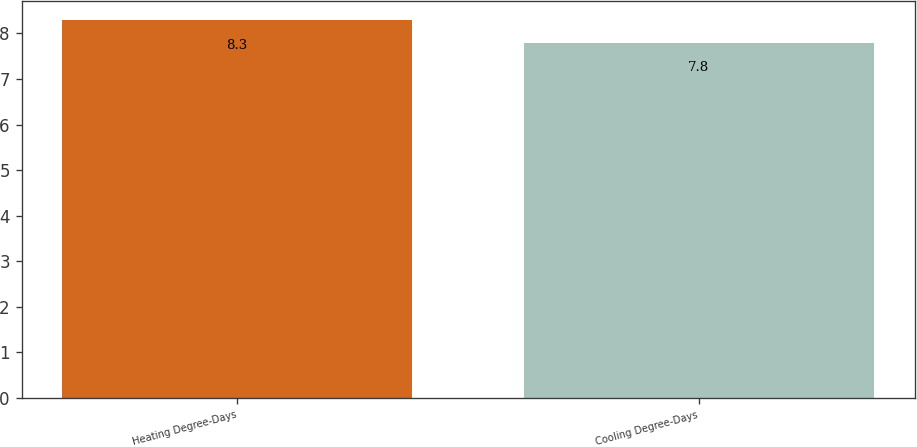Convert chart to OTSL. <chart><loc_0><loc_0><loc_500><loc_500><bar_chart><fcel>Heating Degree-Days<fcel>Cooling Degree-Days<nl><fcel>8.3<fcel>7.8<nl></chart> 